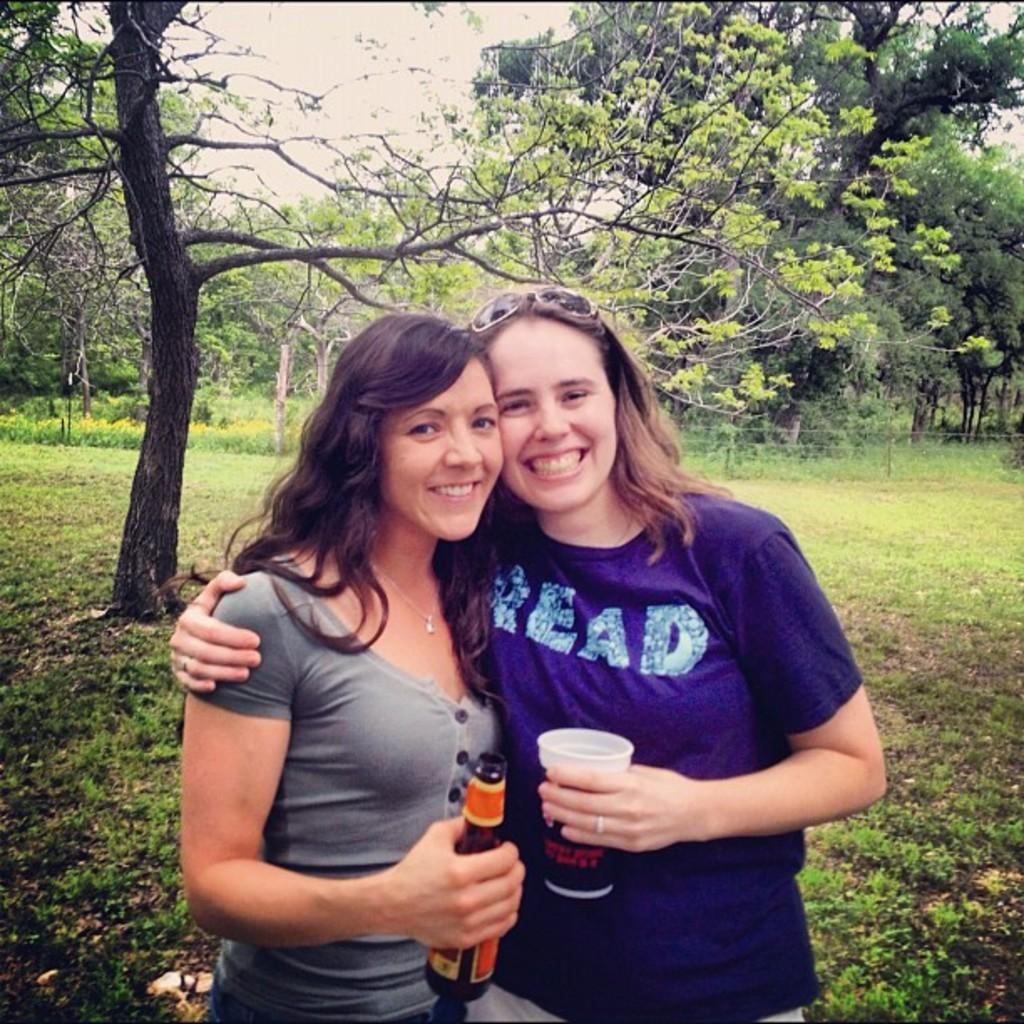How many people are in the image? There are two women in the image. What is the facial expression of the women? The women are smiling. What are the women holding in their hands? The women are holding objects in their hands. What can be seen in the background of the image? There are trees in the background of the image. What is the condition of the stick in the image? There is no stick present in the image. What color is the sky in the image? The provided facts do not mention the color of the sky, so we cannot determine its color from the image. 